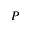<formula> <loc_0><loc_0><loc_500><loc_500>P</formula> 